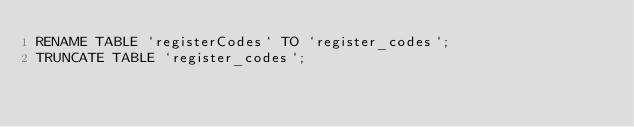Convert code to text. <code><loc_0><loc_0><loc_500><loc_500><_SQL_>RENAME TABLE `registerCodes` TO `register_codes`;
TRUNCATE TABLE `register_codes`;</code> 